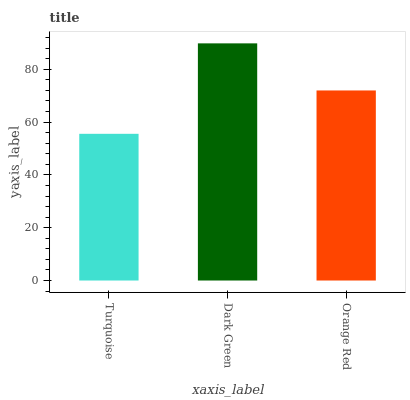Is Turquoise the minimum?
Answer yes or no. Yes. Is Dark Green the maximum?
Answer yes or no. Yes. Is Orange Red the minimum?
Answer yes or no. No. Is Orange Red the maximum?
Answer yes or no. No. Is Dark Green greater than Orange Red?
Answer yes or no. Yes. Is Orange Red less than Dark Green?
Answer yes or no. Yes. Is Orange Red greater than Dark Green?
Answer yes or no. No. Is Dark Green less than Orange Red?
Answer yes or no. No. Is Orange Red the high median?
Answer yes or no. Yes. Is Orange Red the low median?
Answer yes or no. Yes. Is Turquoise the high median?
Answer yes or no. No. Is Turquoise the low median?
Answer yes or no. No. 